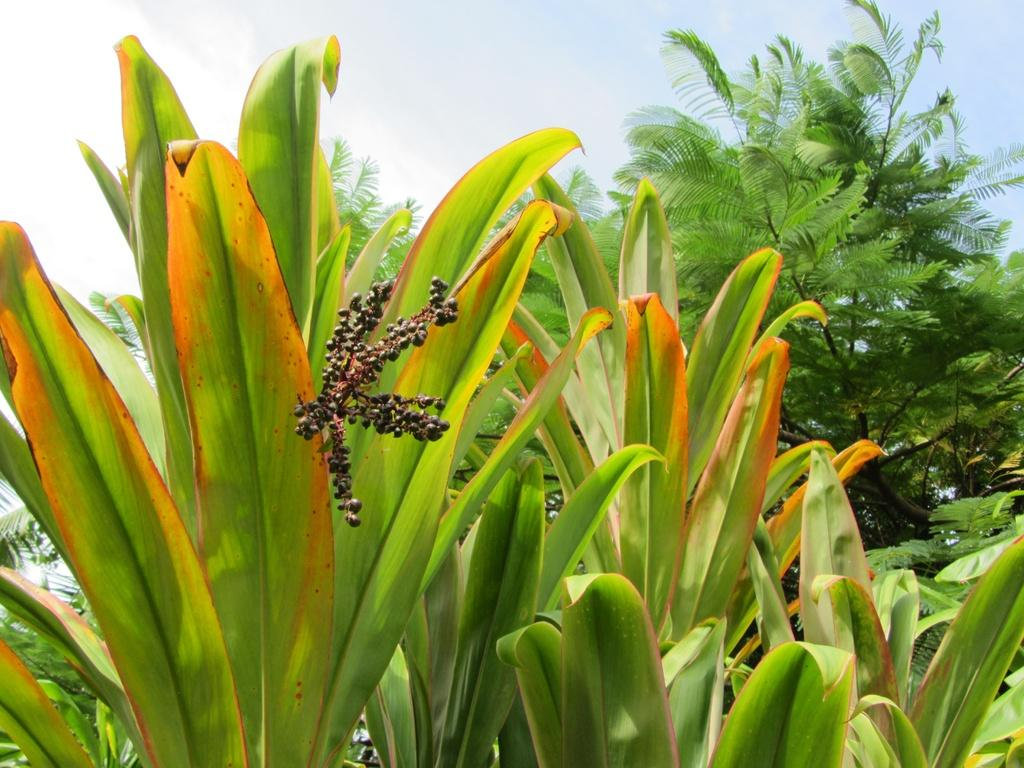What type of plants can be seen in the image? There are plants with green leaves in the image. What can be seen in the background of the image? There are trees in the background of the image. How would you describe the sky in the image? The sky is blue and has clouds in it. What type of breakfast is being served on the table in the image? There is no table or breakfast present in the image; it features plants, trees, and a blue sky with clouds. How many apples are hanging from the trees in the image? There are no apples visible in the image; only green leaves on plants and trees are present. 